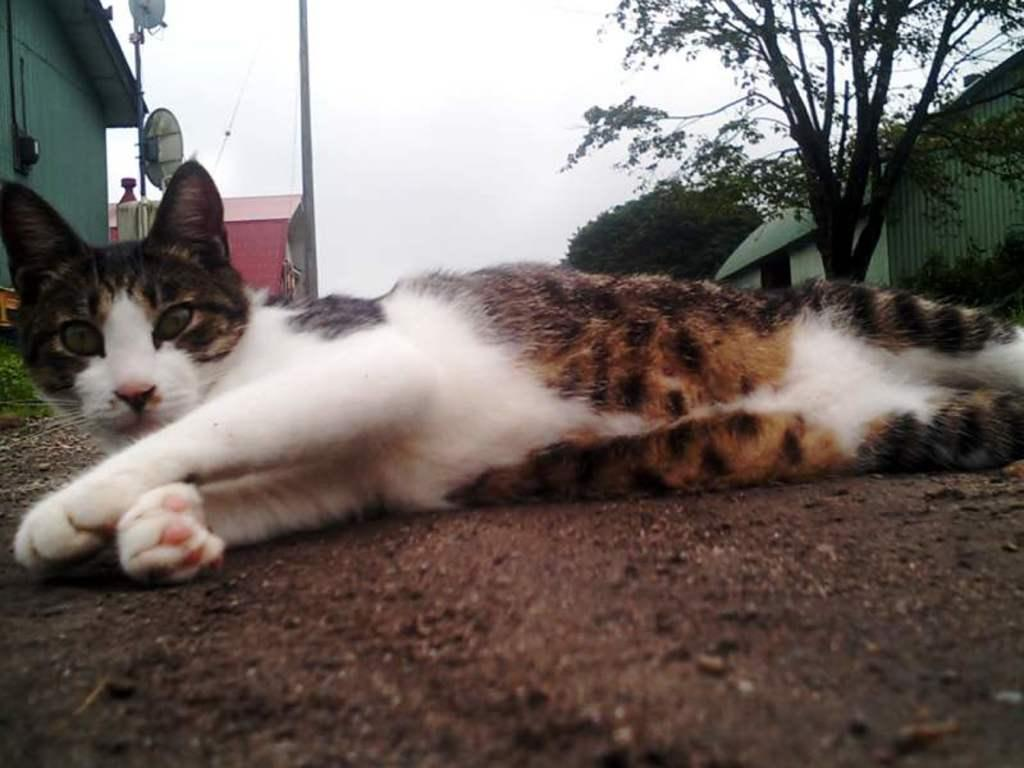What animal is in the front of the image? There is a cat in the front of the image. What type of natural scenery can be seen in the background of the image? There are trees in the background of the image. What type of structures can be seen in the background of the image? There are sheds in the background of the image. What is visible in the sky in the background of the image? The sky is visible in the background of the image. What else can be seen in the background of the image? There are objects in the background of the image. What type of coat is the cat wearing in the image? The cat is not wearing a coat in the image. What book is the cat reading in the image? The cat is not reading a book in the image. 